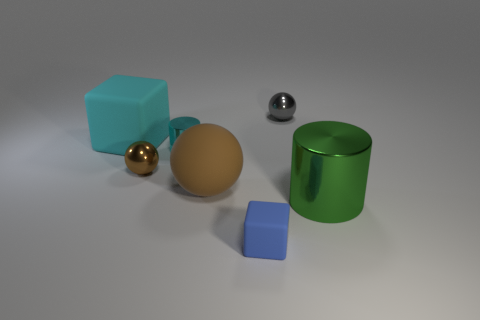Add 1 small brown rubber cylinders. How many objects exist? 8 Subtract all tiny spheres. How many spheres are left? 1 Subtract 2 cylinders. How many cylinders are left? 0 Subtract all brown metal things. Subtract all gray metal balls. How many objects are left? 5 Add 7 blue things. How many blue things are left? 8 Add 7 large rubber things. How many large rubber things exist? 9 Subtract all gray balls. How many balls are left? 2 Subtract 0 purple spheres. How many objects are left? 7 Subtract all cylinders. How many objects are left? 5 Subtract all cyan spheres. Subtract all purple blocks. How many spheres are left? 3 